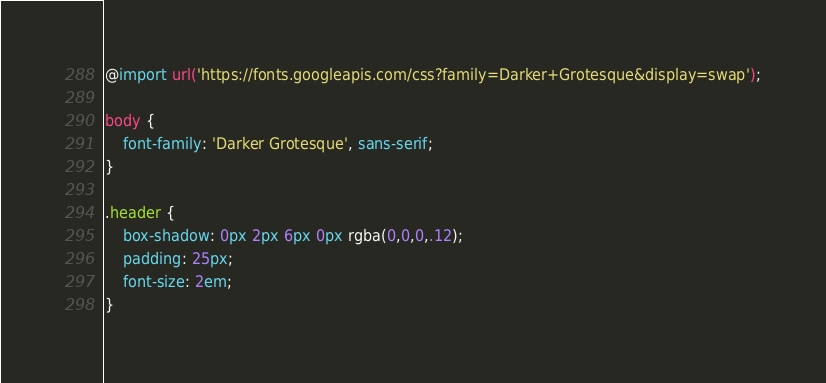Convert code to text. <code><loc_0><loc_0><loc_500><loc_500><_CSS_>@import url('https://fonts.googleapis.com/css?family=Darker+Grotesque&display=swap');

body {
    font-family: 'Darker Grotesque', sans-serif;
}

.header {
    box-shadow: 0px 2px 6px 0px rgba(0,0,0,.12);
    padding: 25px;
    font-size: 2em; 
}

</code> 